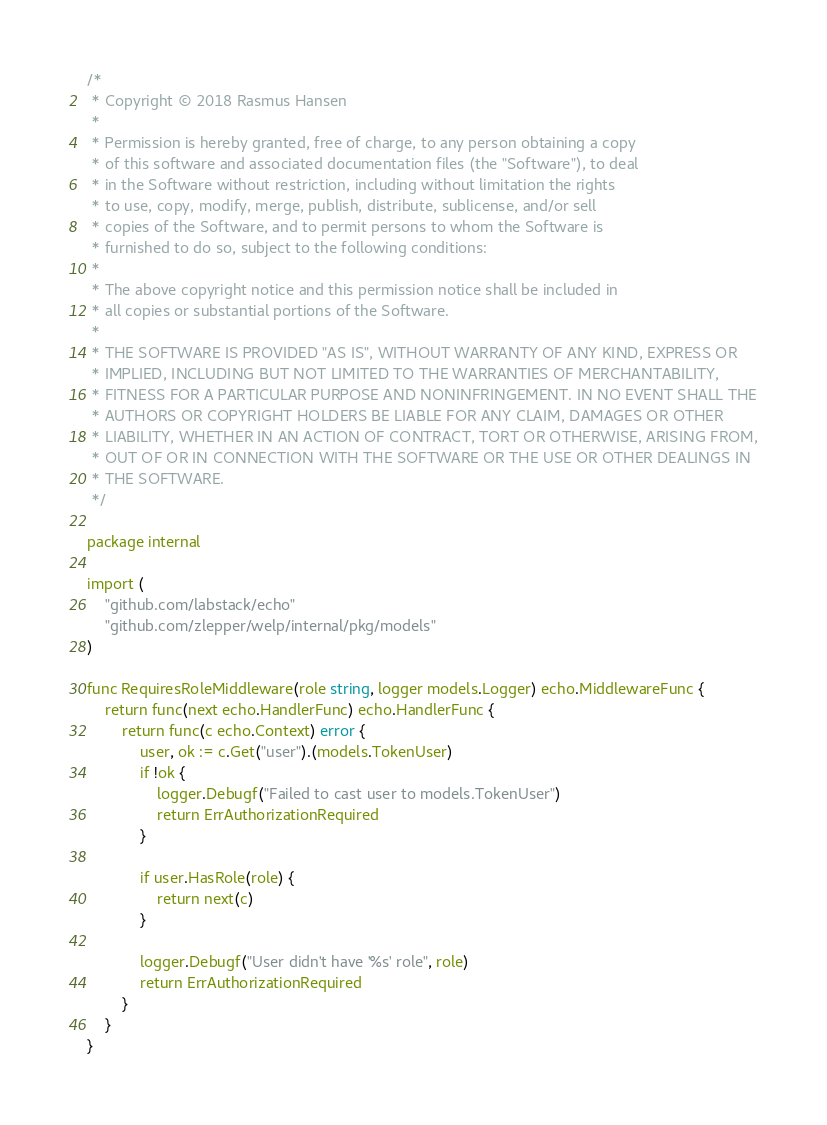<code> <loc_0><loc_0><loc_500><loc_500><_Go_>/*
 * Copyright © 2018 Rasmus Hansen
 *
 * Permission is hereby granted, free of charge, to any person obtaining a copy
 * of this software and associated documentation files (the "Software"), to deal
 * in the Software without restriction, including without limitation the rights
 * to use, copy, modify, merge, publish, distribute, sublicense, and/or sell
 * copies of the Software, and to permit persons to whom the Software is
 * furnished to do so, subject to the following conditions:
 *
 * The above copyright notice and this permission notice shall be included in
 * all copies or substantial portions of the Software.
 *
 * THE SOFTWARE IS PROVIDED "AS IS", WITHOUT WARRANTY OF ANY KIND, EXPRESS OR
 * IMPLIED, INCLUDING BUT NOT LIMITED TO THE WARRANTIES OF MERCHANTABILITY,
 * FITNESS FOR A PARTICULAR PURPOSE AND NONINFRINGEMENT. IN NO EVENT SHALL THE
 * AUTHORS OR COPYRIGHT HOLDERS BE LIABLE FOR ANY CLAIM, DAMAGES OR OTHER
 * LIABILITY, WHETHER IN AN ACTION OF CONTRACT, TORT OR OTHERWISE, ARISING FROM,
 * OUT OF OR IN CONNECTION WITH THE SOFTWARE OR THE USE OR OTHER DEALINGS IN
 * THE SOFTWARE.
 */

package internal

import (
	"github.com/labstack/echo"
	"github.com/zlepper/welp/internal/pkg/models"
)

func RequiresRoleMiddleware(role string, logger models.Logger) echo.MiddlewareFunc {
	return func(next echo.HandlerFunc) echo.HandlerFunc {
		return func(c echo.Context) error {
			user, ok := c.Get("user").(models.TokenUser)
			if !ok {
				logger.Debugf("Failed to cast user to models.TokenUser")
				return ErrAuthorizationRequired
			}

			if user.HasRole(role) {
				return next(c)
			}

			logger.Debugf("User didn't have '%s' role", role)
			return ErrAuthorizationRequired
		}
	}
}
</code> 